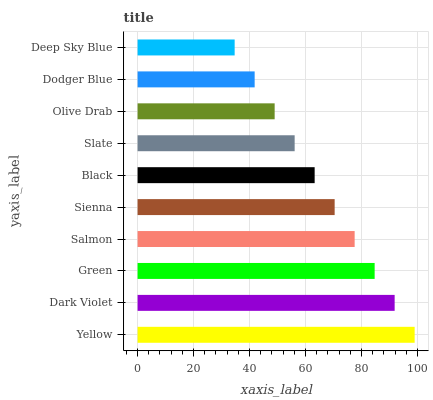Is Deep Sky Blue the minimum?
Answer yes or no. Yes. Is Yellow the maximum?
Answer yes or no. Yes. Is Dark Violet the minimum?
Answer yes or no. No. Is Dark Violet the maximum?
Answer yes or no. No. Is Yellow greater than Dark Violet?
Answer yes or no. Yes. Is Dark Violet less than Yellow?
Answer yes or no. Yes. Is Dark Violet greater than Yellow?
Answer yes or no. No. Is Yellow less than Dark Violet?
Answer yes or no. No. Is Sienna the high median?
Answer yes or no. Yes. Is Black the low median?
Answer yes or no. Yes. Is Yellow the high median?
Answer yes or no. No. Is Green the low median?
Answer yes or no. No. 